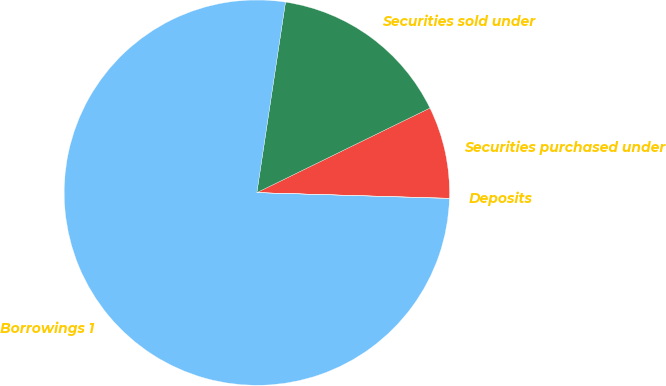Convert chart to OTSL. <chart><loc_0><loc_0><loc_500><loc_500><pie_chart><fcel>Securities purchased under<fcel>Securities sold under<fcel>Borrowings 1<fcel>Deposits<nl><fcel>7.7%<fcel>15.39%<fcel>76.89%<fcel>0.02%<nl></chart> 